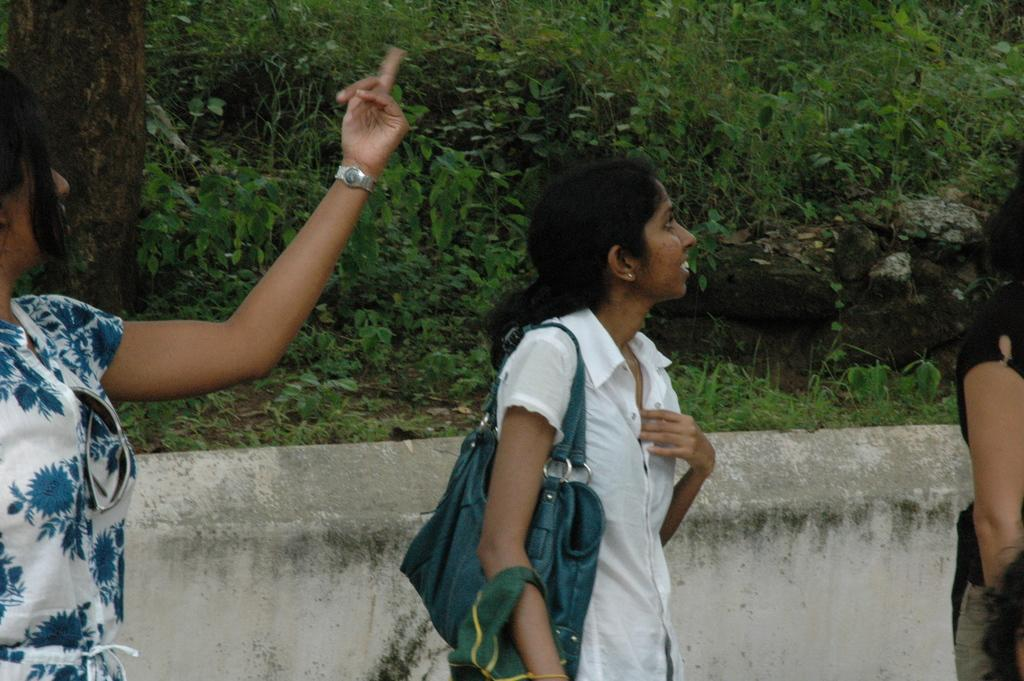How many women are in the image? There are three women in the image. What are the women doing in the image? The women are standing on the floor. Can you describe the clothing of one of the women? One of the women is wearing a bag. What can be seen in the background of the image? There is a group of plants and a tree in the background of the image. What type of throat lozenges are the women using in the image? There is no indication in the image that the women are using throat lozenges, so it cannot be determined from the picture. 